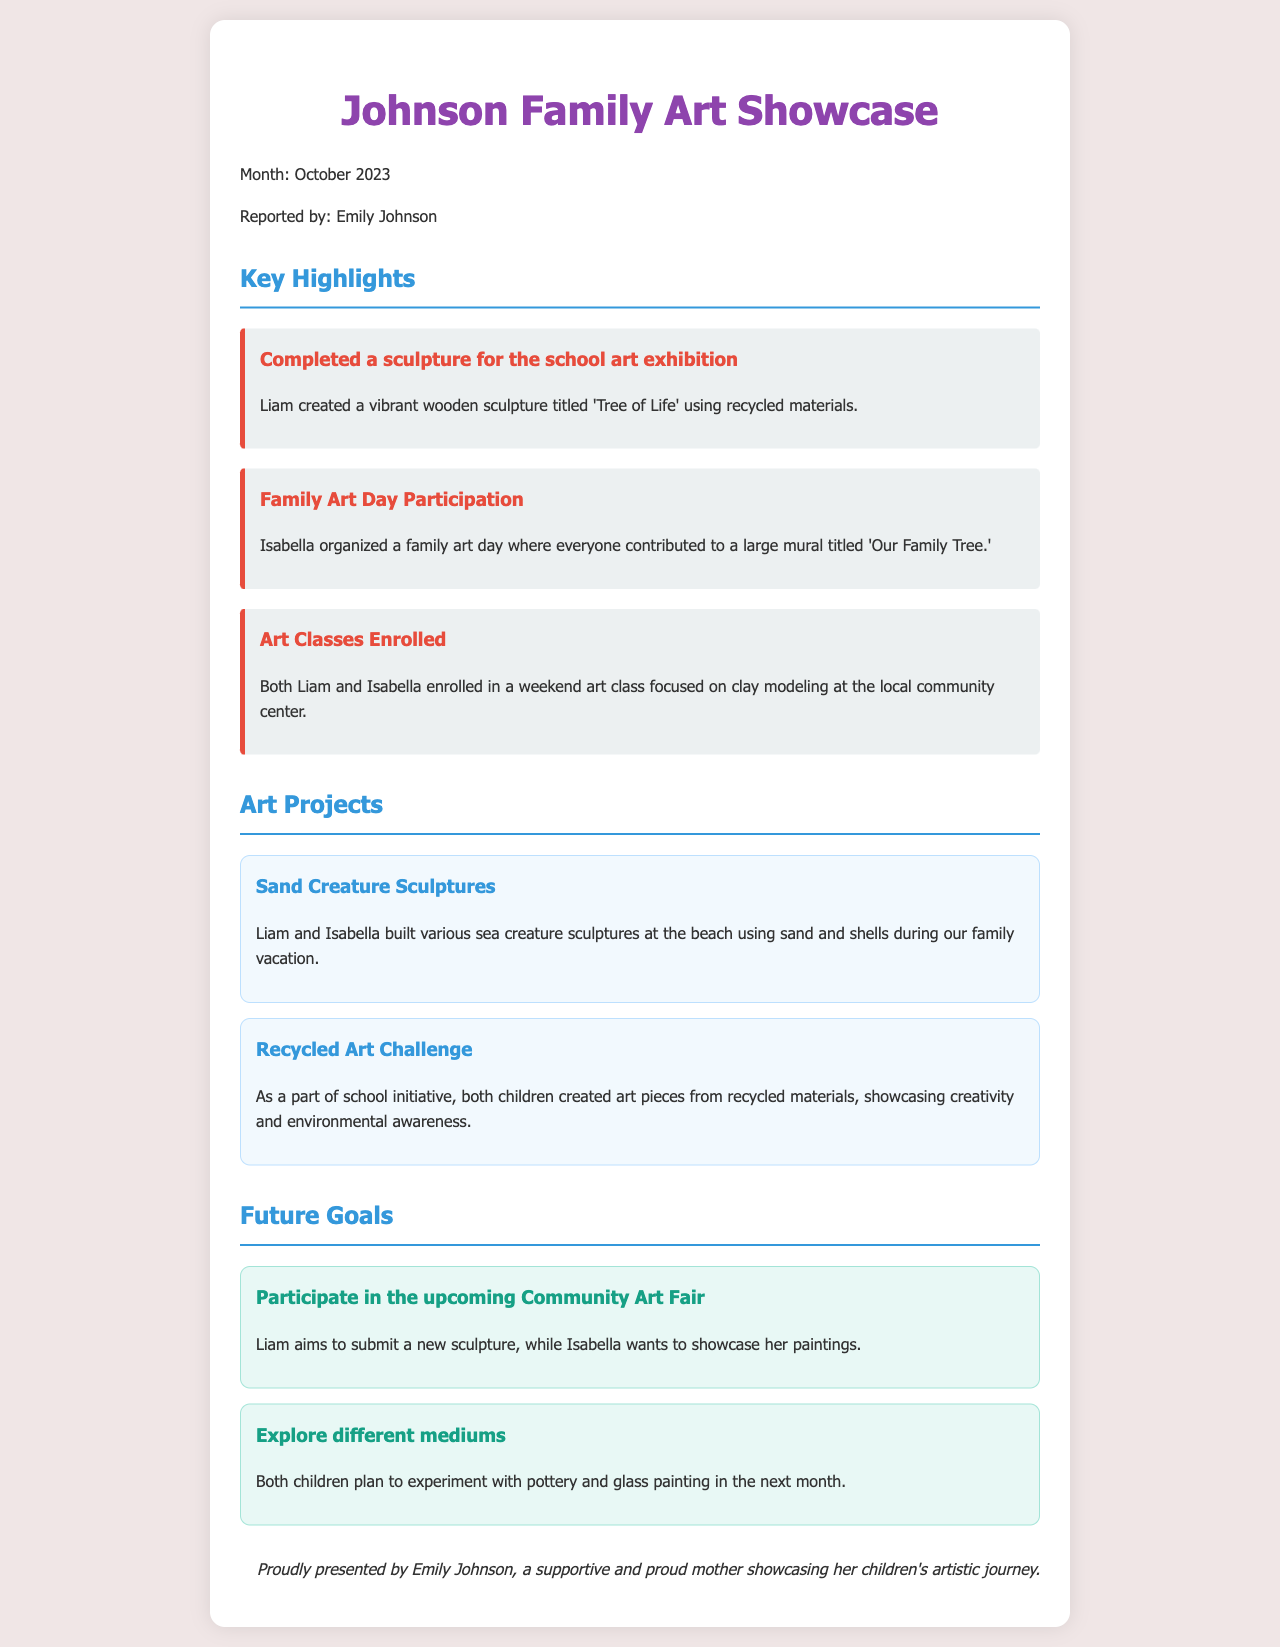what is the title of the sculpture created by Liam? The title of the sculpture is mentioned in the highlights section, specifically referring to Liam's creation.
Answer: Tree of Life who organized the family art day? The document highlights who took responsibility for the family art day, which involved creating a mural.
Answer: Isabella how many art classes did Liam and Isabella enroll in? The document states the number of art classes both children are participating in.
Answer: One what art project did Liam and Isabella work on at the beach? The document describes the specific activity they engaged in during the family vacation at the beach.
Answer: Sand Creature Sculptures what is one of the future goals for Liam? The future goals section outlines what Liam aims to achieve going forward, focusing on his participation in the Community Art Fair.
Answer: Submit a new sculpture how did the art pieces created by the children during the Recycled Art Challenge contribute to their development? This question requires looking at the reasoning behind this project, which fostered certain values and skills in the children.
Answer: Creativity and environmental awareness what title was given to the large mural created during family art day? The document provides the specific title given to the mural created by the family.
Answer: Our Family Tree what is the planned medium both children want to experiment with next month? The future goals section includes mention of specific mediums the children want to work with in the upcoming month.
Answer: Pottery and glass painting 